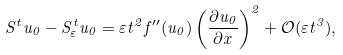Convert formula to latex. <formula><loc_0><loc_0><loc_500><loc_500>S ^ { t } u _ { 0 } - S ^ { t } _ { \varepsilon } u _ { 0 } = \varepsilon t ^ { 2 } f ^ { \prime \prime } ( u _ { 0 } ) \left ( \frac { \partial u _ { 0 } } { \partial x } \right ) ^ { 2 } + \mathcal { O } ( \varepsilon t ^ { 3 } ) ,</formula> 